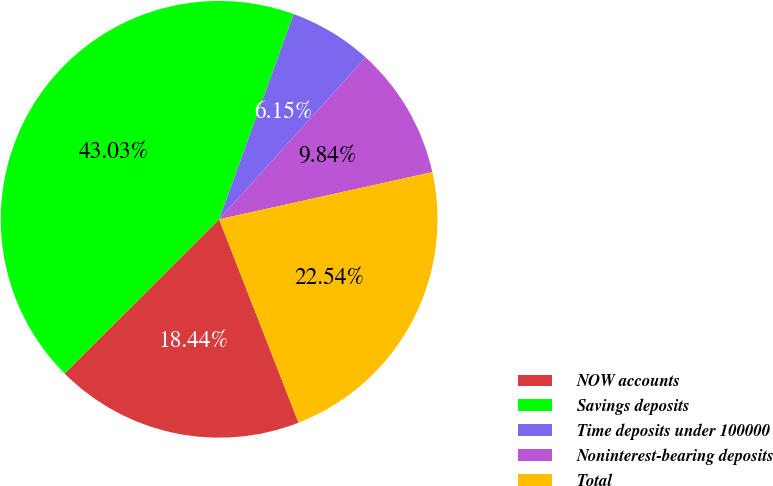Convert chart. <chart><loc_0><loc_0><loc_500><loc_500><pie_chart><fcel>NOW accounts<fcel>Savings deposits<fcel>Time deposits under 100000<fcel>Noninterest-bearing deposits<fcel>Total<nl><fcel>18.44%<fcel>43.03%<fcel>6.15%<fcel>9.84%<fcel>22.54%<nl></chart> 